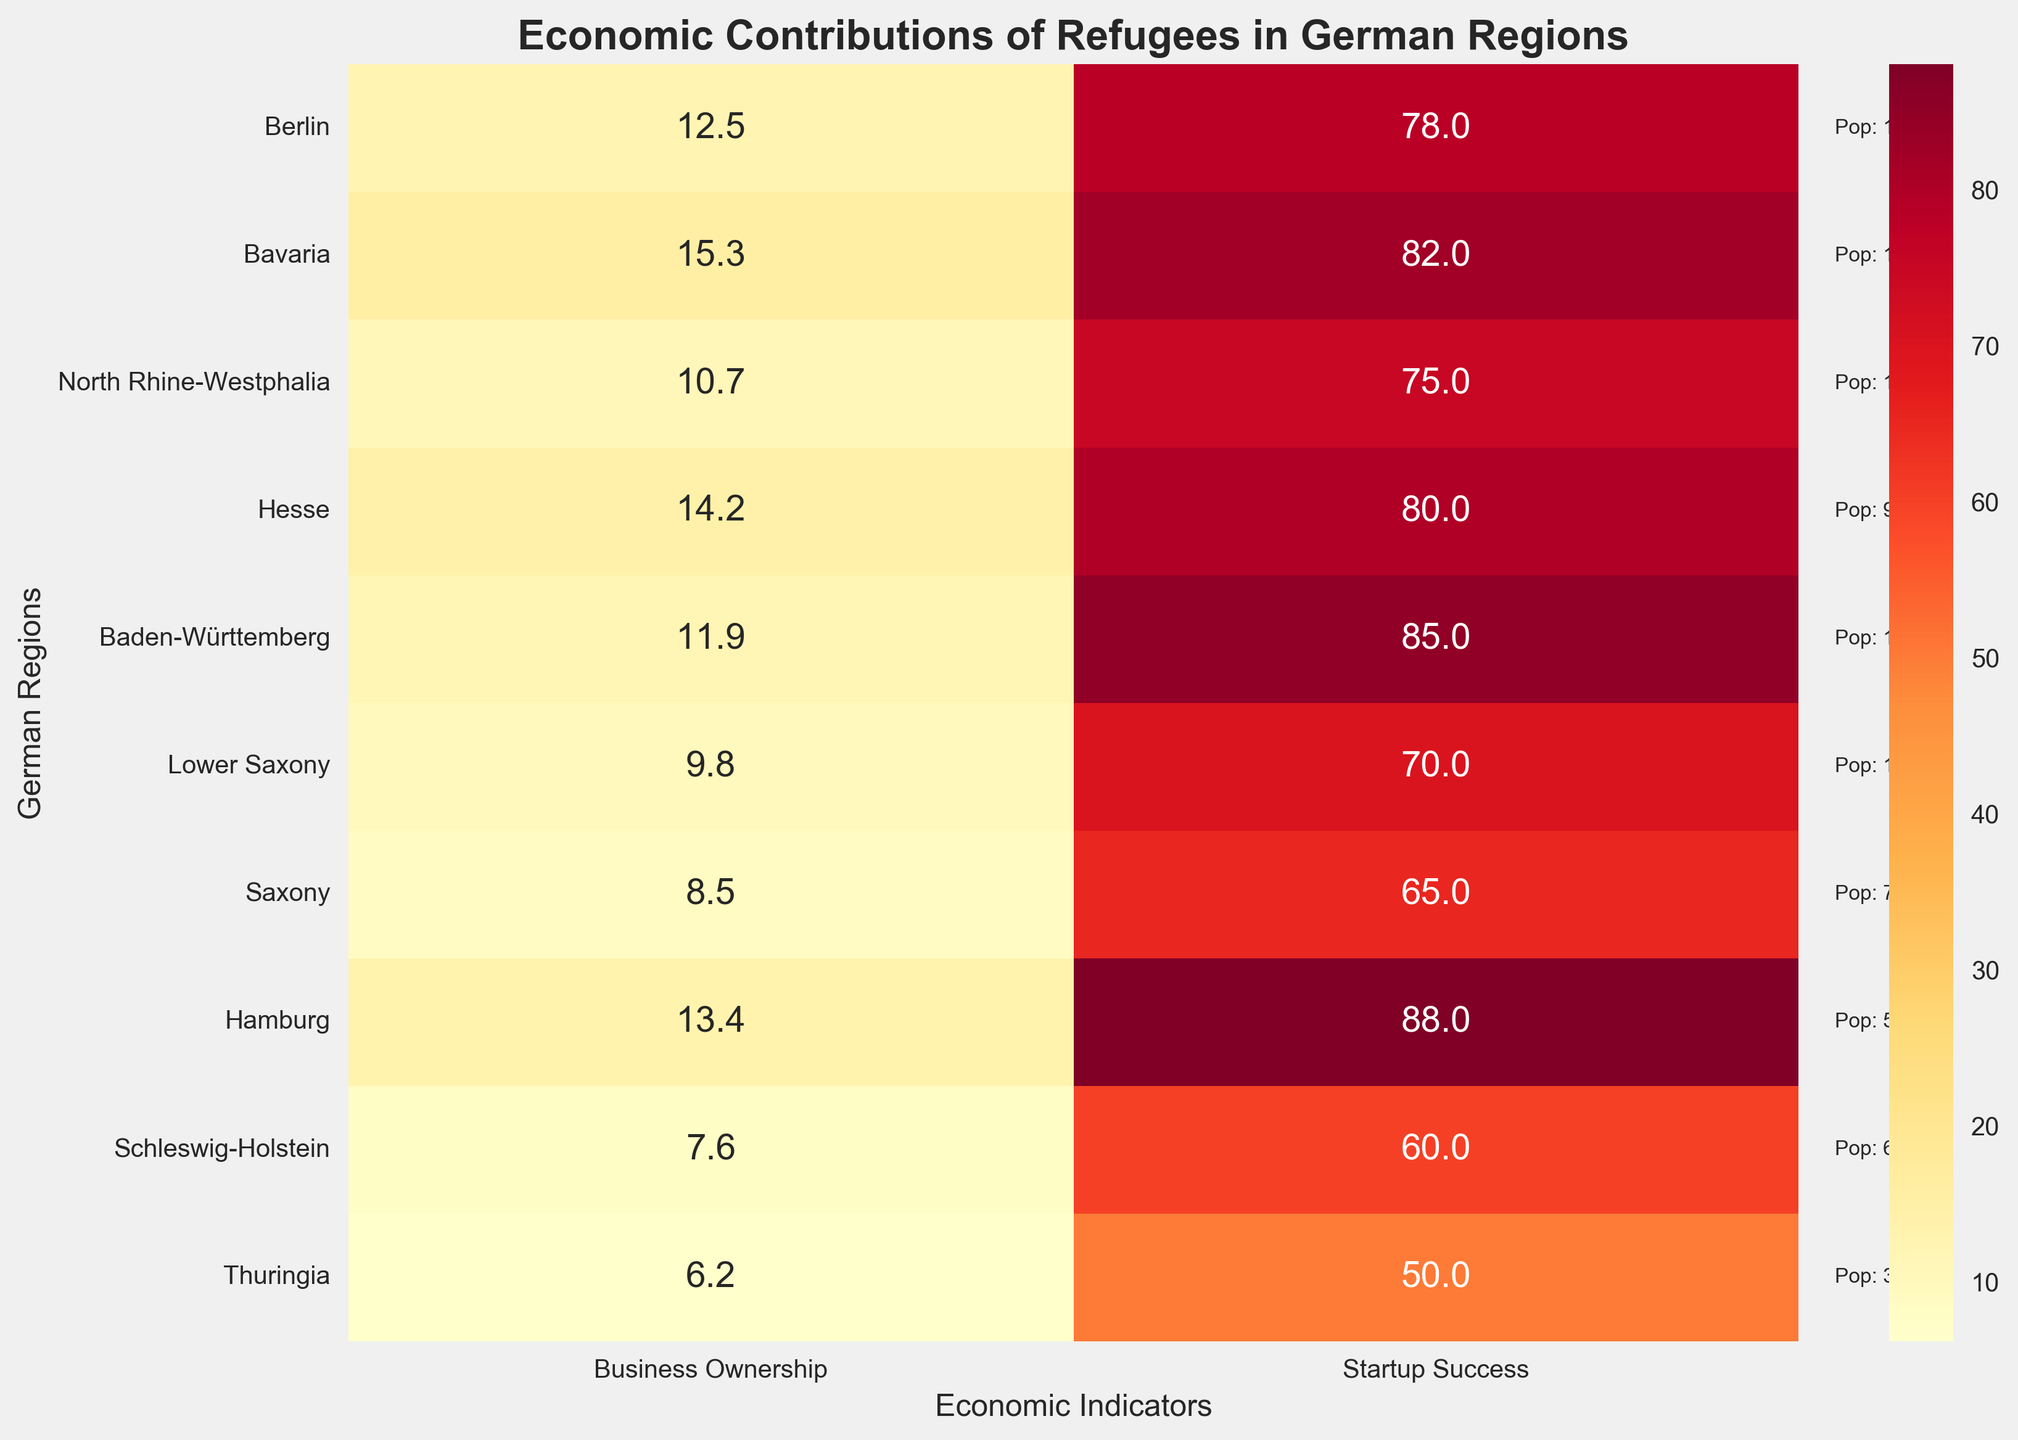What is the title of the figure? The title is displayed at the top of the figure in bold font. It reads "Economic Contributions of Refugees in German Regions".
Answer: Economic Contributions of Refugees in German Regions Which region has the highest percentage of successful startups? By looking at the “Startup Success” column, Hamburg shows the highest percentage of successful startups, which is 88%.
Answer: Hamburg What is the range of the percentage of refugees involved in business? To find the range, identify the minimum and maximum values in the “Business Ownership” column. The highest is 15.3% in Bavaria, and the lowest is 6.2% in Thuringia. The range is the difference: 15.3% - 6.2% = 9.1%.
Answer: 9.1% What is the average percentage of successful startups across all regions? Add up all the percentages of successful startups and divide by the number of regions. (78 + 82 + 75 + 80 + 85 + 70 + 65 + 88 + 60 + 50) / 10 = 73.3%.
Answer: 73.3% Which region has the largest total refugee population? Next to the corresponding y-axis tick labels in the heatmap, the annotated text inside the figure shows population numbers. North Rhine-Westphalia has the largest total refugee population, 18,000.
Answer: North Rhine-Westphalia Compare Berlin and Saxony: Which has a higher percentage of refugees running businesses? By comparing the values in the "Business Ownership" column for Berlin (12.5%) and Saxony (8.5%), Berlin has a higher percentage.
Answer: Berlin What is the percentage difference in successful startups between Bavaria and Lower Saxony? Subtract the percentage of successful startups in Lower Saxony from Bavaria. 82% - 70% = 12%.
Answer: 12% Which region has the lowest percentage of refugees involved in business, and what is that percentage? Identify the region with the lowest value in the “Business Ownership” column, which is Thuringia with 6.2%.
Answer: Thuringia, 6.2% How do the percentages of successful startups compare between Hesse and Baden-Württemberg? Both values in the "Startup Success" column need to be identified: Hesse (80%) and Baden-Württemberg (85%). Baden-Württemberg has a higher percentage.
Answer: Baden-Württemberg 